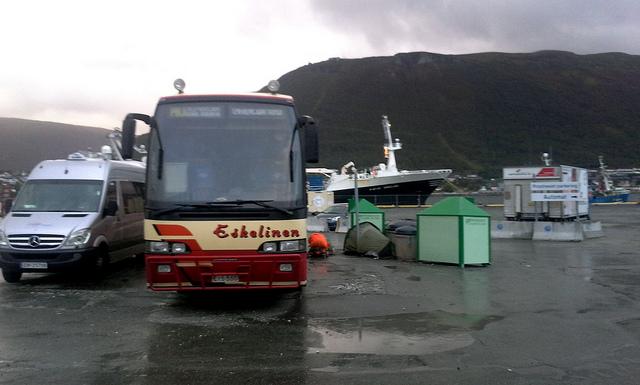What color are the cars next to the bus?
Write a very short answer. Silver. How many means of transportation are here?
Give a very brief answer. 3. Are these German suburban trains?
Answer briefly. No. What brand of van is on the left?
Quick response, please. Mercedes. 